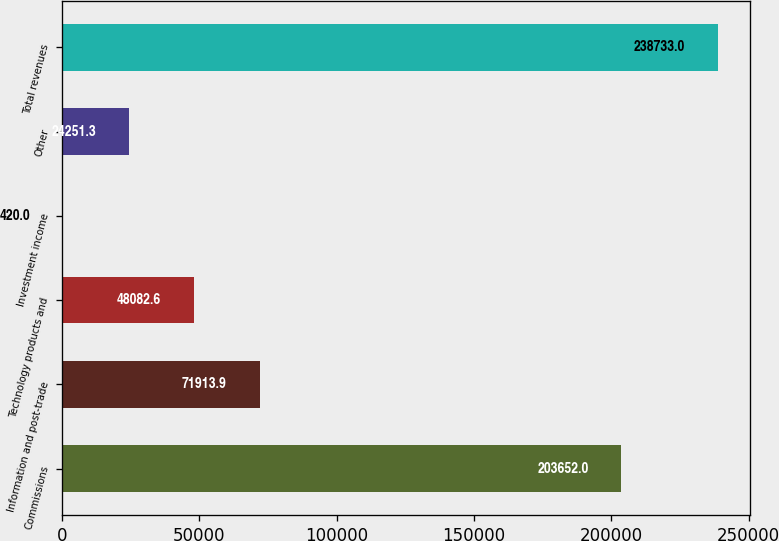Convert chart to OTSL. <chart><loc_0><loc_0><loc_500><loc_500><bar_chart><fcel>Commissions<fcel>Information and post-trade<fcel>Technology products and<fcel>Investment income<fcel>Other<fcel>Total revenues<nl><fcel>203652<fcel>71913.9<fcel>48082.6<fcel>420<fcel>24251.3<fcel>238733<nl></chart> 